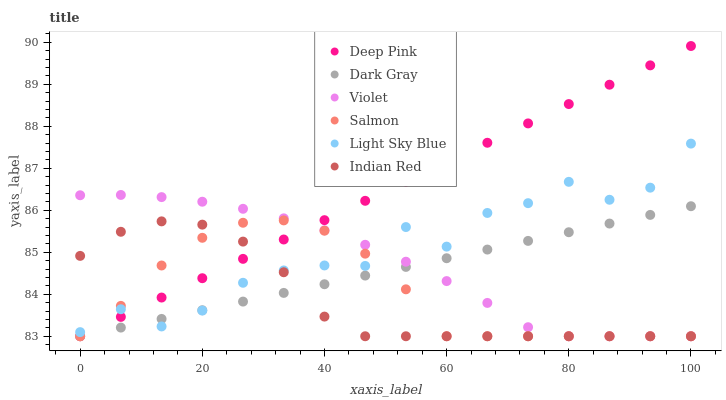Does Indian Red have the minimum area under the curve?
Answer yes or no. Yes. Does Deep Pink have the maximum area under the curve?
Answer yes or no. Yes. Does Salmon have the minimum area under the curve?
Answer yes or no. No. Does Salmon have the maximum area under the curve?
Answer yes or no. No. Is Dark Gray the smoothest?
Answer yes or no. Yes. Is Light Sky Blue the roughest?
Answer yes or no. Yes. Is Salmon the smoothest?
Answer yes or no. No. Is Salmon the roughest?
Answer yes or no. No. Does Deep Pink have the lowest value?
Answer yes or no. Yes. Does Light Sky Blue have the lowest value?
Answer yes or no. No. Does Deep Pink have the highest value?
Answer yes or no. Yes. Does Salmon have the highest value?
Answer yes or no. No. Does Violet intersect Dark Gray?
Answer yes or no. Yes. Is Violet less than Dark Gray?
Answer yes or no. No. Is Violet greater than Dark Gray?
Answer yes or no. No. 